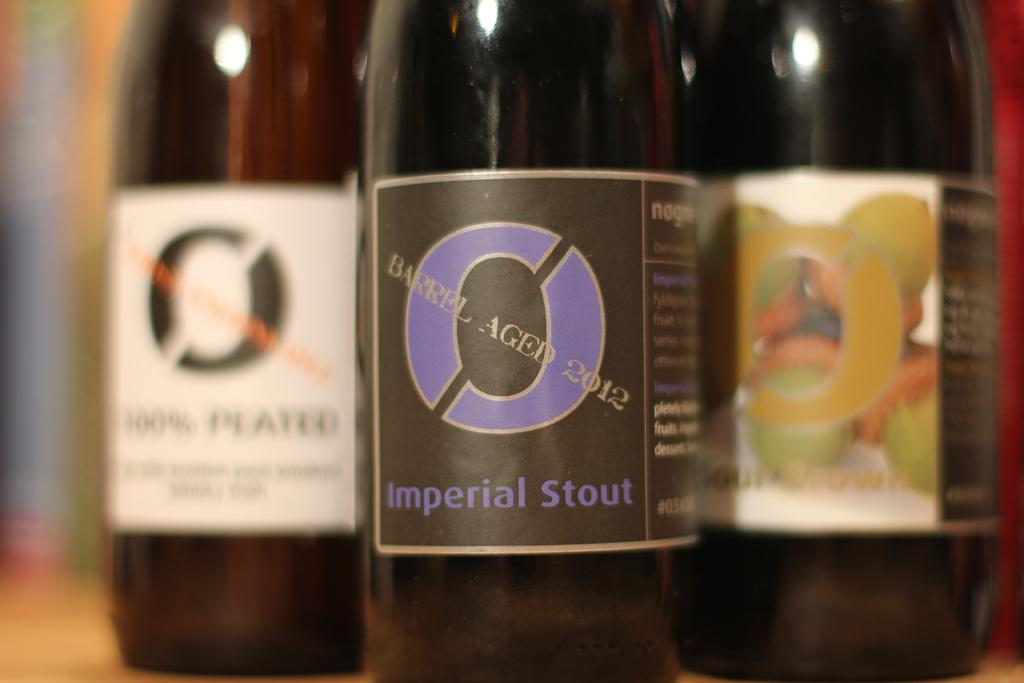How many bottles are visible in the image? There are three bottles in the image. What color are the bottles? The bottles are brown in color. Are there any additional features on the bottles? Yes, there are stickers on the bottles. What type of eggnog is being served in space in the image? There is no reference to eggnog or space in the image; it only features three brown bottles with stickers on them. 